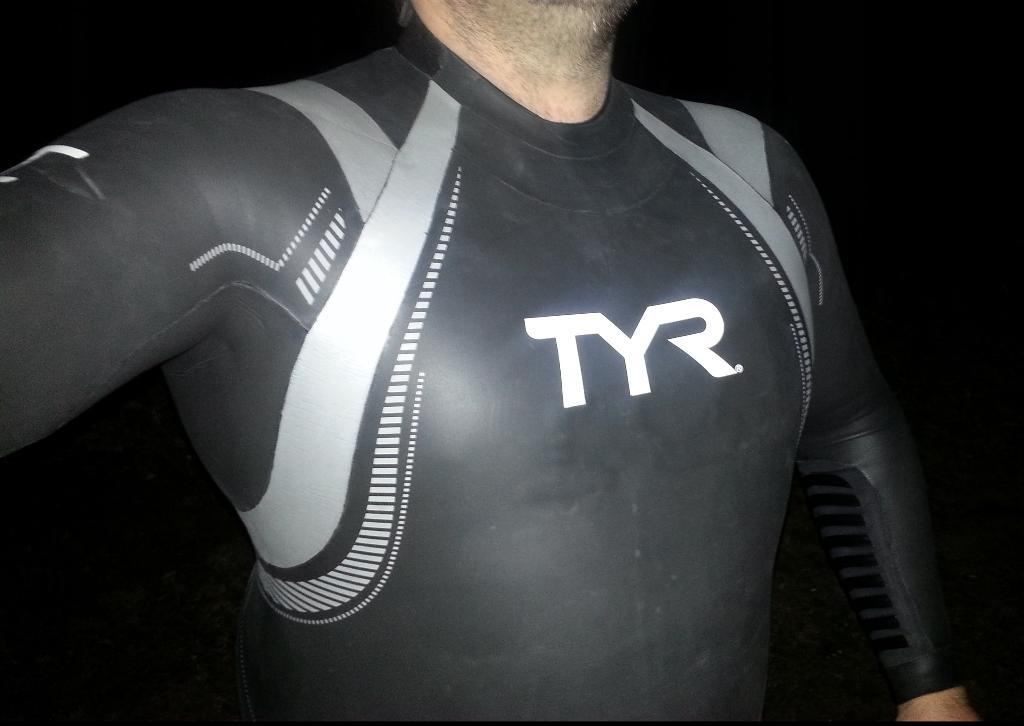What is the main subject of the image? There is a person in the image. How is the person depicted in the image? The person is truncated. What can be observed about the background of the image? The background of the image is dark. How much blood has the person lost in the image? There is no indication of blood loss in the image, as it only shows a person who is truncated against a dark background. 